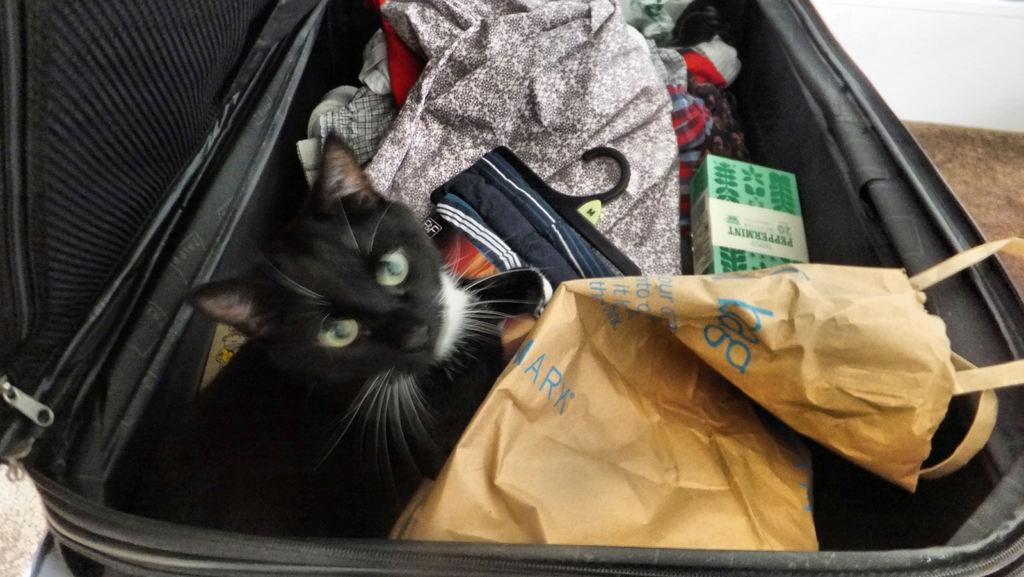What object can be seen in the picture? There is a suitcase in the picture. What is inside the suitcase? A cat is present in the suitcase. What else can be seen in the picture besides the suitcase? There are clothes visible in the picture. What type of design is on the monkey's shirt in the picture? There is no monkey present in the picture, so it is not possible to determine the design on its shirt. 